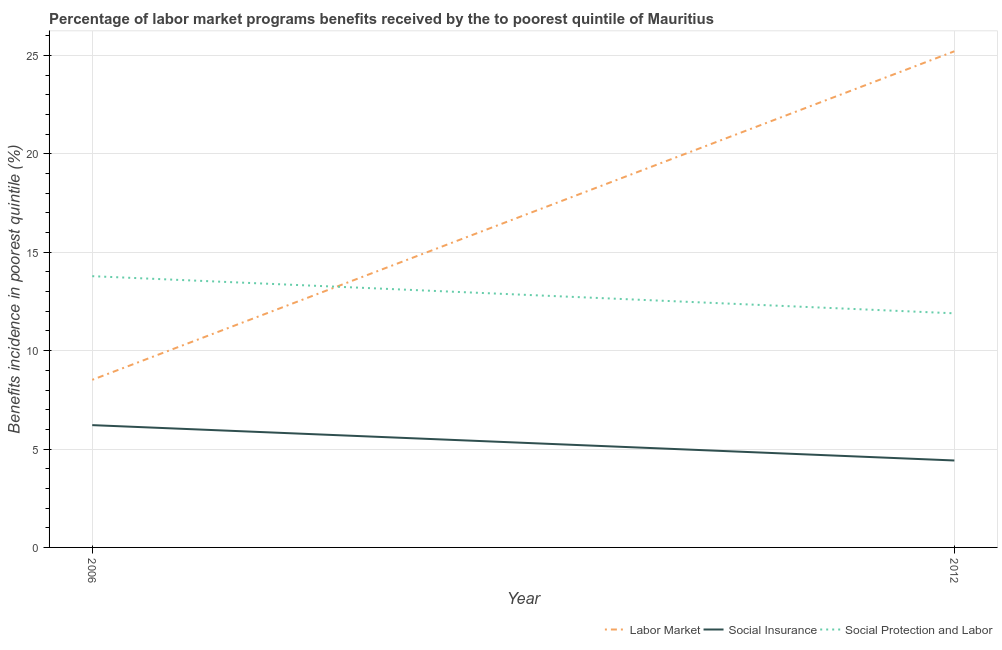What is the percentage of benefits received due to social insurance programs in 2006?
Your response must be concise. 6.22. Across all years, what is the maximum percentage of benefits received due to labor market programs?
Provide a succinct answer. 25.22. Across all years, what is the minimum percentage of benefits received due to labor market programs?
Your answer should be compact. 8.52. In which year was the percentage of benefits received due to labor market programs maximum?
Give a very brief answer. 2012. In which year was the percentage of benefits received due to labor market programs minimum?
Provide a succinct answer. 2006. What is the total percentage of benefits received due to social insurance programs in the graph?
Your answer should be very brief. 10.63. What is the difference between the percentage of benefits received due to social insurance programs in 2006 and that in 2012?
Your answer should be very brief. 1.8. What is the difference between the percentage of benefits received due to social insurance programs in 2012 and the percentage of benefits received due to social protection programs in 2006?
Your answer should be compact. -9.37. What is the average percentage of benefits received due to social insurance programs per year?
Make the answer very short. 5.32. In the year 2006, what is the difference between the percentage of benefits received due to labor market programs and percentage of benefits received due to social protection programs?
Your answer should be compact. -5.27. What is the ratio of the percentage of benefits received due to labor market programs in 2006 to that in 2012?
Your answer should be very brief. 0.34. In how many years, is the percentage of benefits received due to social protection programs greater than the average percentage of benefits received due to social protection programs taken over all years?
Provide a succinct answer. 1. Is it the case that in every year, the sum of the percentage of benefits received due to labor market programs and percentage of benefits received due to social insurance programs is greater than the percentage of benefits received due to social protection programs?
Your answer should be very brief. Yes. How many lines are there?
Provide a succinct answer. 3. What is the difference between two consecutive major ticks on the Y-axis?
Give a very brief answer. 5. Are the values on the major ticks of Y-axis written in scientific E-notation?
Offer a very short reply. No. Does the graph contain any zero values?
Your response must be concise. No. Does the graph contain grids?
Ensure brevity in your answer.  Yes. How many legend labels are there?
Give a very brief answer. 3. What is the title of the graph?
Provide a succinct answer. Percentage of labor market programs benefits received by the to poorest quintile of Mauritius. Does "Agricultural raw materials" appear as one of the legend labels in the graph?
Keep it short and to the point. No. What is the label or title of the X-axis?
Give a very brief answer. Year. What is the label or title of the Y-axis?
Provide a succinct answer. Benefits incidence in poorest quintile (%). What is the Benefits incidence in poorest quintile (%) in Labor Market in 2006?
Provide a succinct answer. 8.52. What is the Benefits incidence in poorest quintile (%) of Social Insurance in 2006?
Keep it short and to the point. 6.22. What is the Benefits incidence in poorest quintile (%) in Social Protection and Labor in 2006?
Your answer should be compact. 13.79. What is the Benefits incidence in poorest quintile (%) in Labor Market in 2012?
Your answer should be compact. 25.22. What is the Benefits incidence in poorest quintile (%) of Social Insurance in 2012?
Your response must be concise. 4.42. What is the Benefits incidence in poorest quintile (%) in Social Protection and Labor in 2012?
Keep it short and to the point. 11.9. Across all years, what is the maximum Benefits incidence in poorest quintile (%) in Labor Market?
Your answer should be very brief. 25.22. Across all years, what is the maximum Benefits incidence in poorest quintile (%) in Social Insurance?
Make the answer very short. 6.22. Across all years, what is the maximum Benefits incidence in poorest quintile (%) in Social Protection and Labor?
Keep it short and to the point. 13.79. Across all years, what is the minimum Benefits incidence in poorest quintile (%) of Labor Market?
Offer a terse response. 8.52. Across all years, what is the minimum Benefits incidence in poorest quintile (%) in Social Insurance?
Ensure brevity in your answer.  4.42. Across all years, what is the minimum Benefits incidence in poorest quintile (%) in Social Protection and Labor?
Offer a terse response. 11.9. What is the total Benefits incidence in poorest quintile (%) of Labor Market in the graph?
Your answer should be very brief. 33.73. What is the total Benefits incidence in poorest quintile (%) in Social Insurance in the graph?
Provide a succinct answer. 10.63. What is the total Benefits incidence in poorest quintile (%) in Social Protection and Labor in the graph?
Provide a succinct answer. 25.68. What is the difference between the Benefits incidence in poorest quintile (%) of Labor Market in 2006 and that in 2012?
Ensure brevity in your answer.  -16.7. What is the difference between the Benefits incidence in poorest quintile (%) in Social Insurance in 2006 and that in 2012?
Give a very brief answer. 1.8. What is the difference between the Benefits incidence in poorest quintile (%) of Social Protection and Labor in 2006 and that in 2012?
Keep it short and to the point. 1.89. What is the difference between the Benefits incidence in poorest quintile (%) in Labor Market in 2006 and the Benefits incidence in poorest quintile (%) in Social Insurance in 2012?
Provide a short and direct response. 4.1. What is the difference between the Benefits incidence in poorest quintile (%) in Labor Market in 2006 and the Benefits incidence in poorest quintile (%) in Social Protection and Labor in 2012?
Provide a short and direct response. -3.38. What is the difference between the Benefits incidence in poorest quintile (%) in Social Insurance in 2006 and the Benefits incidence in poorest quintile (%) in Social Protection and Labor in 2012?
Offer a very short reply. -5.68. What is the average Benefits incidence in poorest quintile (%) of Labor Market per year?
Make the answer very short. 16.87. What is the average Benefits incidence in poorest quintile (%) of Social Insurance per year?
Provide a short and direct response. 5.32. What is the average Benefits incidence in poorest quintile (%) of Social Protection and Labor per year?
Offer a very short reply. 12.84. In the year 2006, what is the difference between the Benefits incidence in poorest quintile (%) of Labor Market and Benefits incidence in poorest quintile (%) of Social Insurance?
Your answer should be very brief. 2.3. In the year 2006, what is the difference between the Benefits incidence in poorest quintile (%) in Labor Market and Benefits incidence in poorest quintile (%) in Social Protection and Labor?
Offer a terse response. -5.27. In the year 2006, what is the difference between the Benefits incidence in poorest quintile (%) in Social Insurance and Benefits incidence in poorest quintile (%) in Social Protection and Labor?
Your response must be concise. -7.57. In the year 2012, what is the difference between the Benefits incidence in poorest quintile (%) in Labor Market and Benefits incidence in poorest quintile (%) in Social Insurance?
Your answer should be very brief. 20.8. In the year 2012, what is the difference between the Benefits incidence in poorest quintile (%) in Labor Market and Benefits incidence in poorest quintile (%) in Social Protection and Labor?
Your answer should be compact. 13.32. In the year 2012, what is the difference between the Benefits incidence in poorest quintile (%) in Social Insurance and Benefits incidence in poorest quintile (%) in Social Protection and Labor?
Offer a terse response. -7.48. What is the ratio of the Benefits incidence in poorest quintile (%) in Labor Market in 2006 to that in 2012?
Offer a very short reply. 0.34. What is the ratio of the Benefits incidence in poorest quintile (%) in Social Insurance in 2006 to that in 2012?
Your answer should be very brief. 1.41. What is the ratio of the Benefits incidence in poorest quintile (%) in Social Protection and Labor in 2006 to that in 2012?
Offer a terse response. 1.16. What is the difference between the highest and the second highest Benefits incidence in poorest quintile (%) of Labor Market?
Make the answer very short. 16.7. What is the difference between the highest and the second highest Benefits incidence in poorest quintile (%) in Social Insurance?
Offer a terse response. 1.8. What is the difference between the highest and the second highest Benefits incidence in poorest quintile (%) of Social Protection and Labor?
Your response must be concise. 1.89. What is the difference between the highest and the lowest Benefits incidence in poorest quintile (%) in Labor Market?
Offer a terse response. 16.7. What is the difference between the highest and the lowest Benefits incidence in poorest quintile (%) in Social Insurance?
Provide a succinct answer. 1.8. What is the difference between the highest and the lowest Benefits incidence in poorest quintile (%) in Social Protection and Labor?
Give a very brief answer. 1.89. 